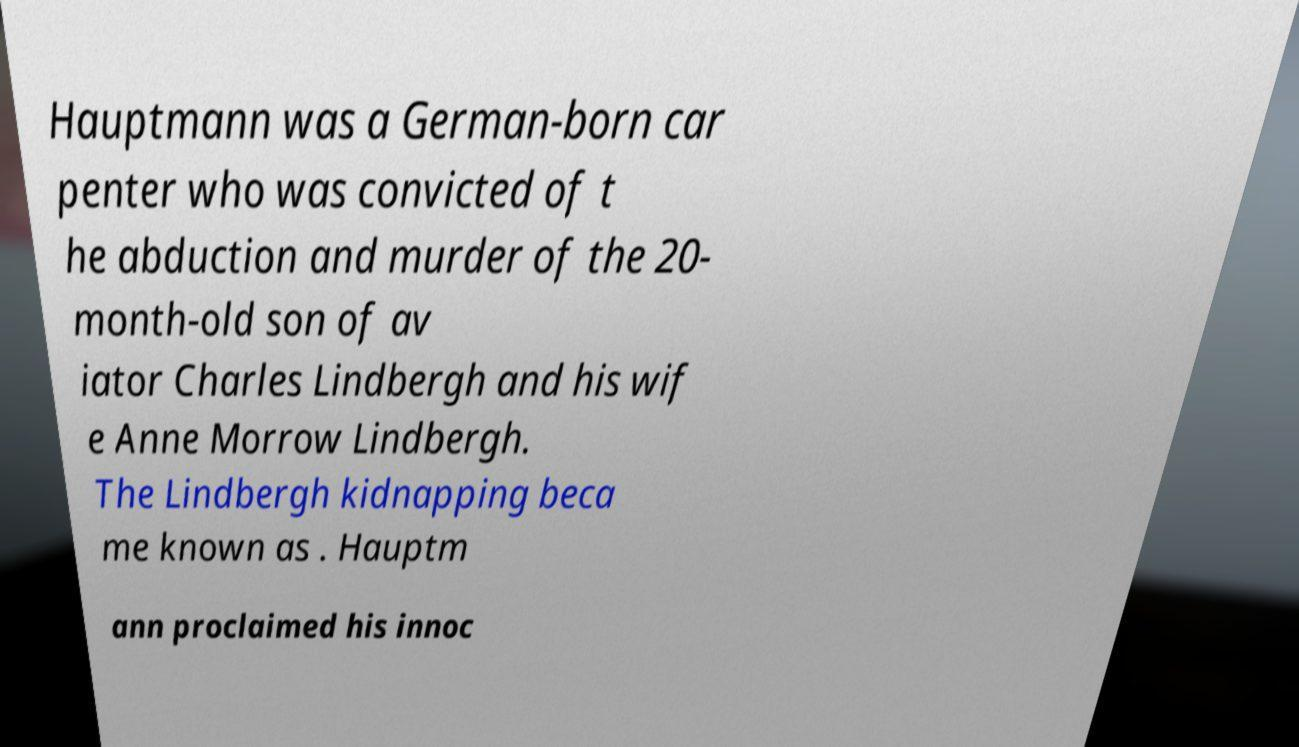Please read and relay the text visible in this image. What does it say? Hauptmann was a German-born car penter who was convicted of t he abduction and murder of the 20- month-old son of av iator Charles Lindbergh and his wif e Anne Morrow Lindbergh. The Lindbergh kidnapping beca me known as . Hauptm ann proclaimed his innoc 